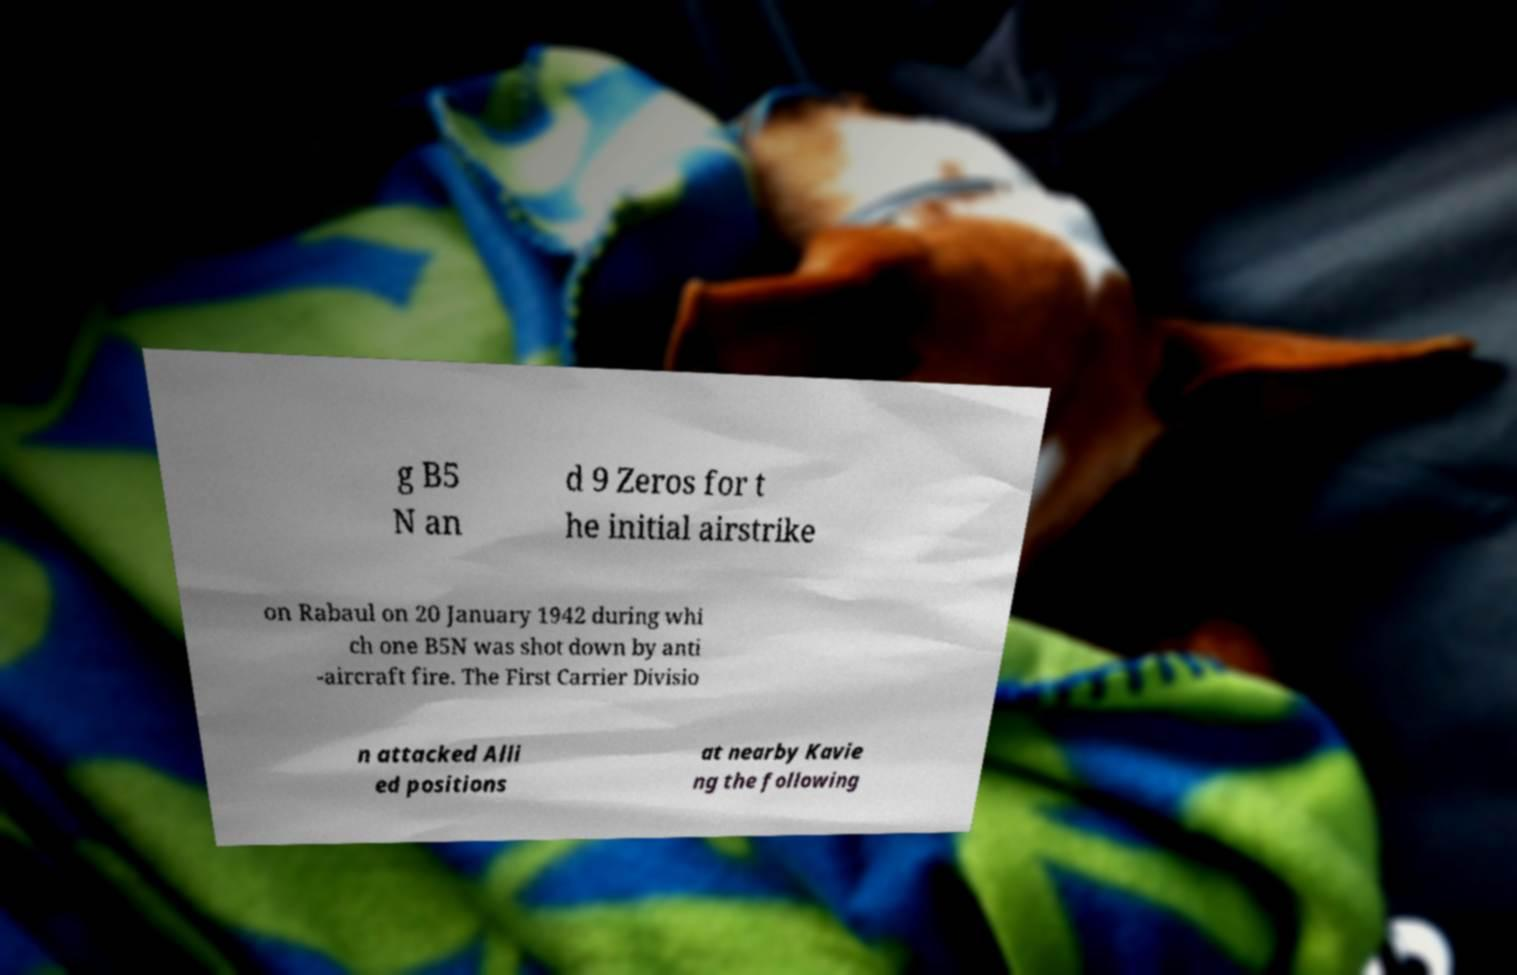Could you assist in decoding the text presented in this image and type it out clearly? g B5 N an d 9 Zeros for t he initial airstrike on Rabaul on 20 January 1942 during whi ch one B5N was shot down by anti -aircraft fire. The First Carrier Divisio n attacked Alli ed positions at nearby Kavie ng the following 